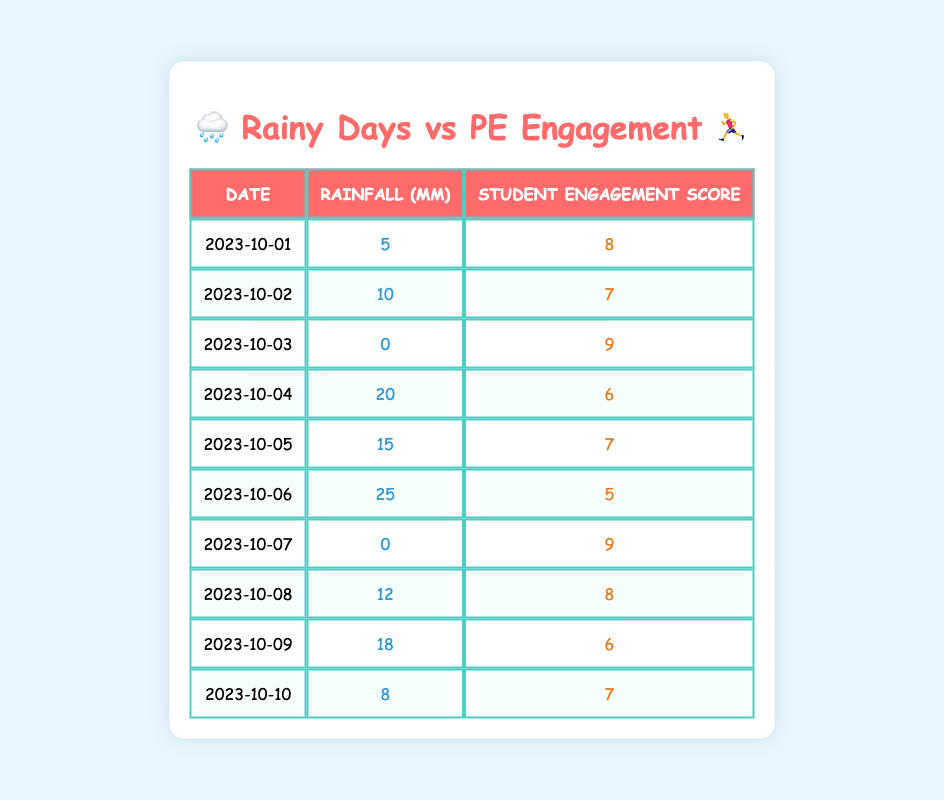What is the highest student engagement score recorded in the table? By reviewing the "Student Engagement Score" column, we see that the highest value listed is 9, which appears on October 3rd and October 7th.
Answer: 9 What is the total rainfall recorded over the ten days? To find the total rainfall, I will sum the values from the "Rainfall (mm)" column: 5 + 10 + 0 + 20 + 15 + 25 + 0 + 12 + 18 + 8 = 108 mm.
Answer: 108 mm Is there any day where the rainfall was 0 mm? Looking through the "Rainfall (mm)" column, the values 0 appear on October 3rd and October 7th, confirming that there are indeed days with no rainfall.
Answer: Yes What was the average student engagement score on days with more than 10 mm of rainfall? First, identifying the days with more than 10 mm of rainfall: October 2nd (7), October 4th (6), October 5th (7), October 6th (5), October 8th (8), and October 9th (6). Summing these scores gives 7 + 6 + 7 + 5 + 8 + 6 = 39. There are 6 scores, so the average engagement score is 39/6 = 6.5.
Answer: 6.5 What is the correlation between rainfall and student engagement based on the data? To assess correlation, we look at the trends: as rainfall increases, student engagement seems to decline, indicating a possible negative correlation. For more exact measures, further statistical analysis would be needed, but visually it appears they are inversely related.
Answer: Negative correlation How many days had a student engagement score below the average of 7? First, we calculate the average student engagement score from the stated scores. The sum of the engagement scores (8 + 7 + 9 + 6 + 7 + 5 + 9 + 8 + 6 + 7) equals 7.6, so scores below this average are on October 4th, 6th, and 9th. Thus, 3 days had a score below average.
Answer: 3 What is the student engagement score on the day with the highest rainfall? The highest rainfall is on October 6th with 25 mm; on that day, the student engagement score is 5.
Answer: 5 Which day had both high rainfall (more than 20 mm) and the lowest student engagement score? October 6th had the highest rainfall at 25 mm and the lowest student engagement score, which is 5. This matches the condition of high rainfall and being the lowest score.
Answer: October 6th 